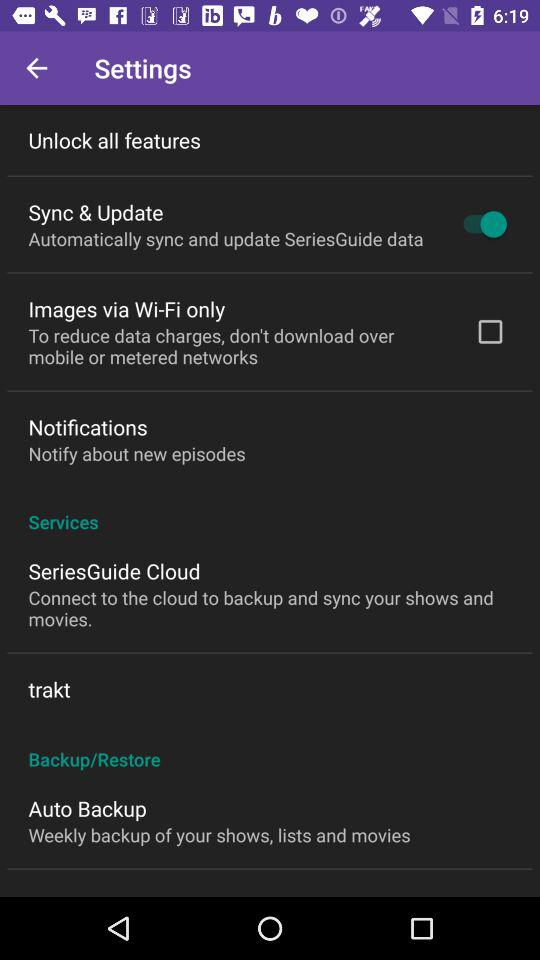What is the current status of the "Image via Wi-Fi only"? The status is off. 